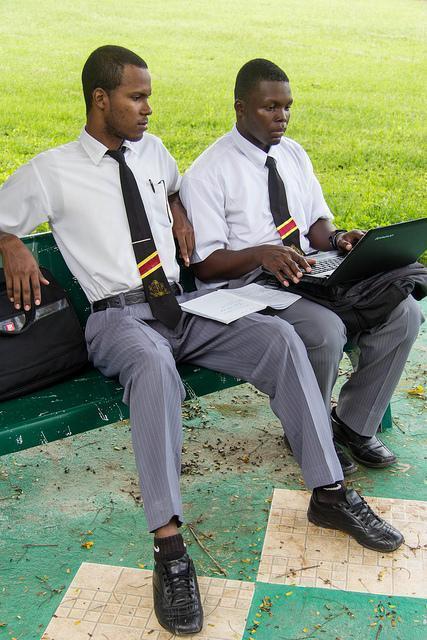How many people are there?
Give a very brief answer. 2. How many handbags are in the photo?
Give a very brief answer. 2. 